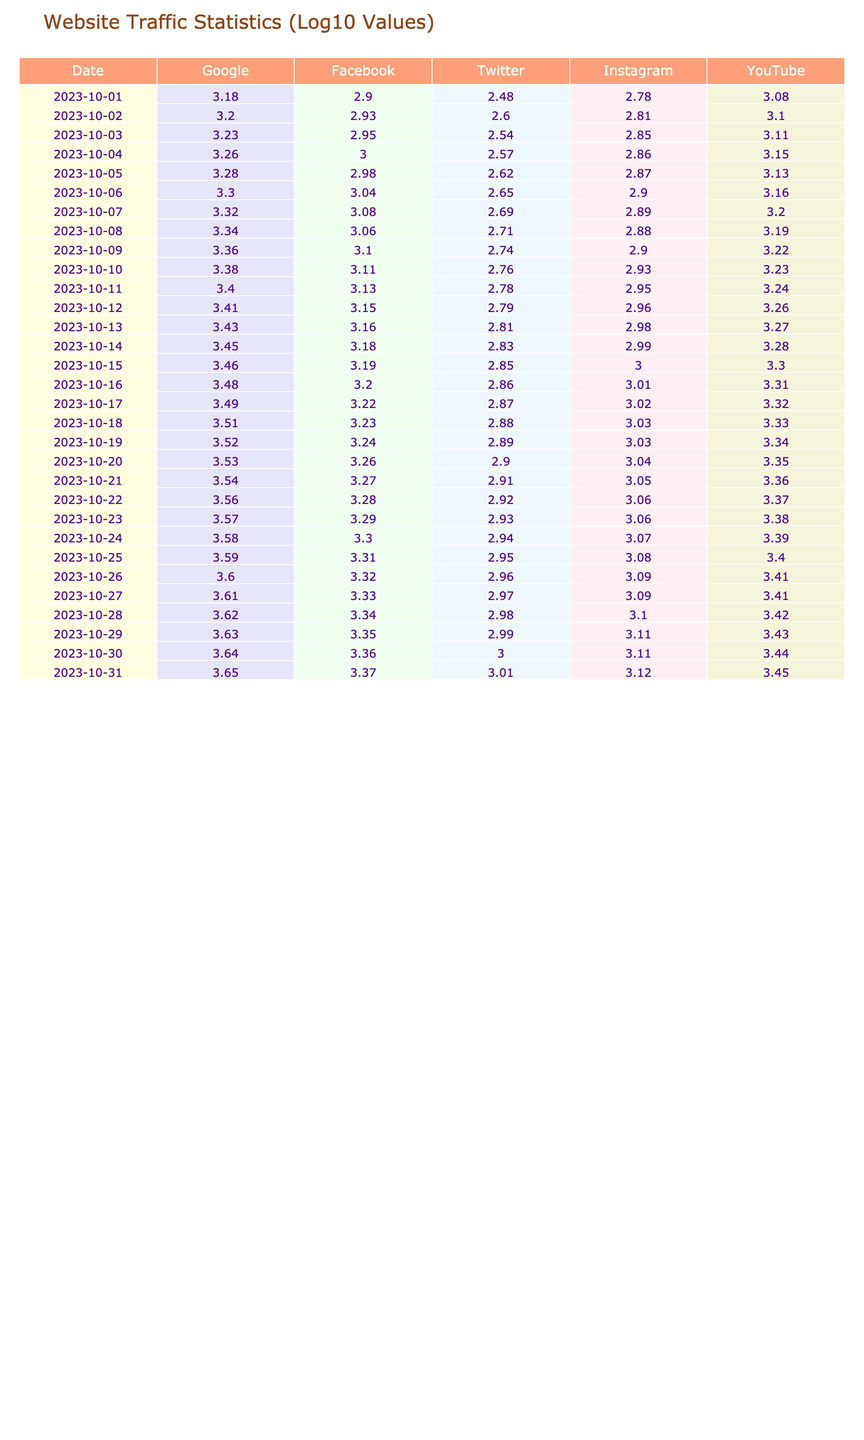What was the website with the highest traffic on October 15? Looking at the table, on October 15, the traffic values for each website are: Google - 2900, Facebook - 1550, Twitter - 700, Instagram - 1000, and YouTube - 2000. The highest value is 2900, which belongs to Google.
Answer: Google What is the average traffic for Instagram over the month? To calculate the average traffic for Instagram, we first add all the Instagram values: 1000 + 1020 + 1040 + 1060 + 1080 + 1100 + 1120 + 1140 + 1160 + 1180 + 1200 + 1220 + 1240 + 1260 + 1280 + 1300 + 1320 = 18180. Then, we divide by the number of days, which is 31, giving us 18180 / 31 = 586.77.
Answer: 586.77 Was there an increase in traffic for YouTube from October 1 to October 31? On October 1, the traffic for YouTube was 1200 and on October 31 it was 2800. Since 2800 > 1200, this confirms an increase.
Answer: Yes On which date did Twitter experience the lowest traffic? By examining the Twitter traffic values, we find that the lowest value is 300 on October 1. No other days have a lower value than this.
Answer: October 1 What is the total traffic for Google over the entire month? We sum all the daily traffic values for Google: 1500 + 1600 + 1700 + 1800 + 1900 + 2000 + 2100 + 2200 + 2300 + 2400 + 2500 + 2600 + 2700 + 2800 + 2900 + 3000 + 3100 + 3200 + 3300 + 3400 + 3500 + 3600 + 3700 + 3800 + 3900 + 4000 + 4100 + 4200 + 4300 + 4400 + 4500 = 102500.
Answer: 102500 Was Instagram's traffic consistently increasing throughout the month? By checking the values for Instagram from October 1 to October 31, they are: 600, 650, 700, 720, 740, 800, 780, 760, 800, 850, 900, 920, 950, 980, 1000, 1020, 1040, 1060, 1080, 1100, 1120, 1140, 1160, 1180, 1200, 1220, 1240, 1260, 1280, 1300, 1320. The values do not strictly increase every day because there are decreases on some days (like October 6 to October 7). Thus, the answer is no.
Answer: No What was the difference in traffic between the highest and lowest days for Facebook? The highest traffic for Facebook is 2350 on October 31 and the lowest traffic is 800 on October 1. The difference is 2350 - 800 = 1550.
Answer: 1550 